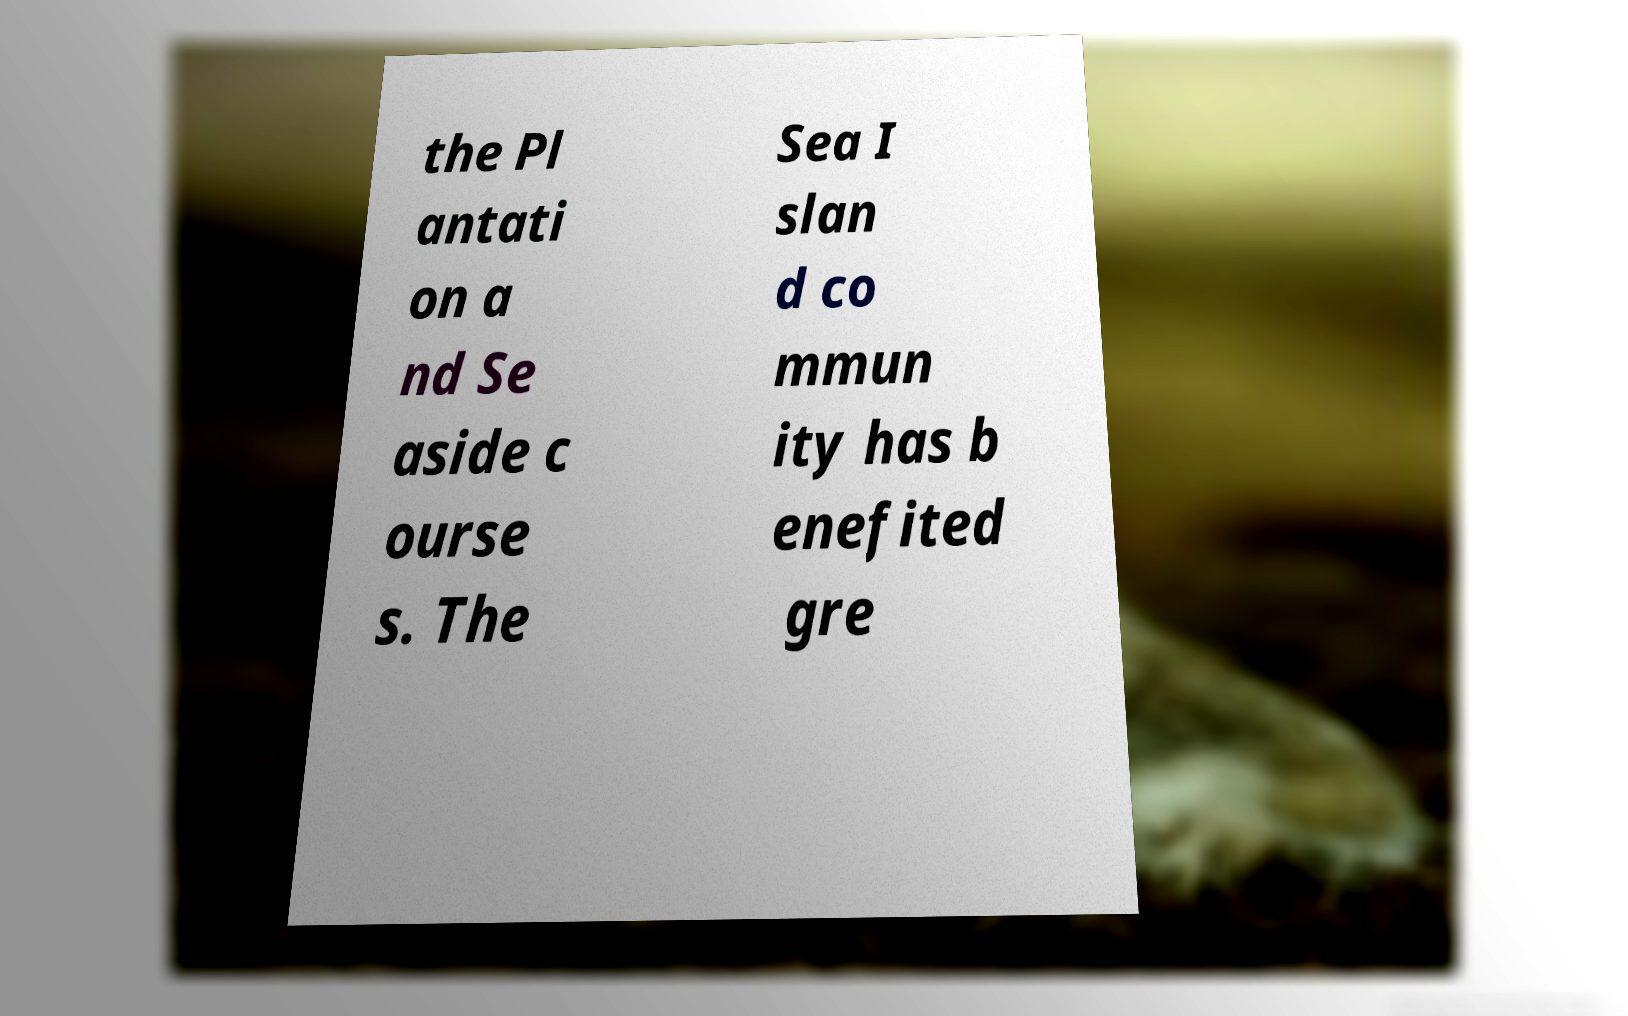Can you accurately transcribe the text from the provided image for me? the Pl antati on a nd Se aside c ourse s. The Sea I slan d co mmun ity has b enefited gre 